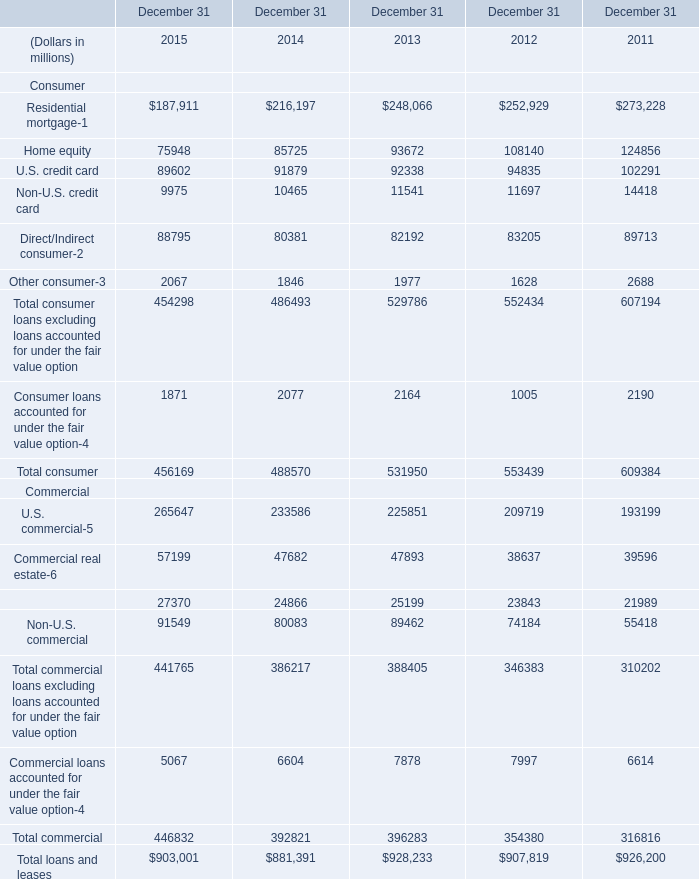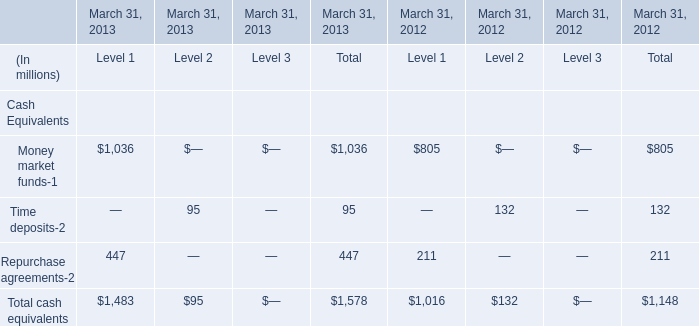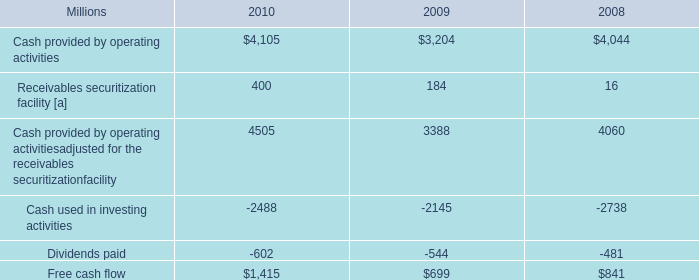What's the average of Free cash flow of 2010, and Commercial real estate Commercial of December 31 2013 ? 
Computations: ((1415.0 + 47893.0) / 2)
Answer: 24654.0. 